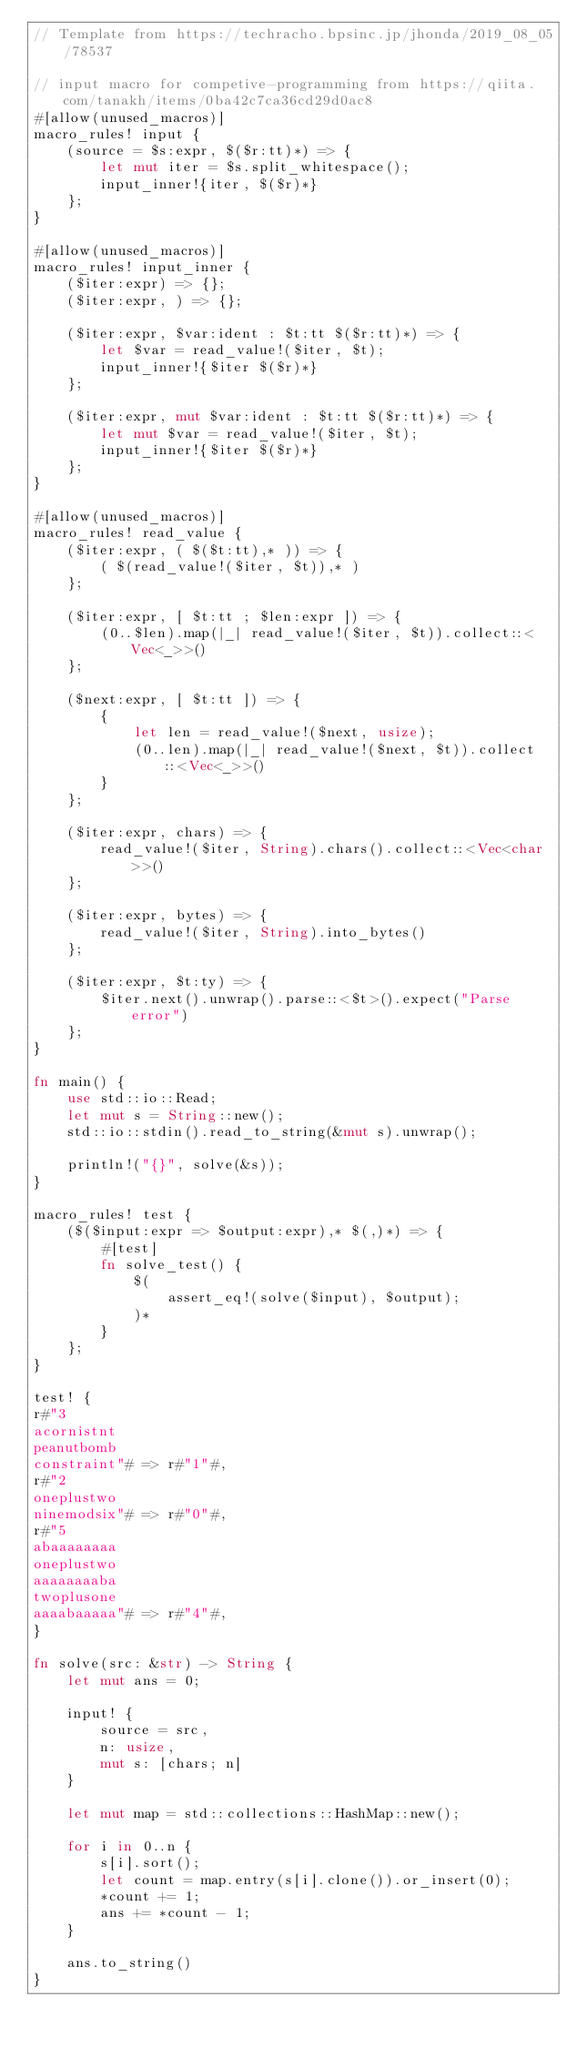<code> <loc_0><loc_0><loc_500><loc_500><_Rust_>// Template from https://techracho.bpsinc.jp/jhonda/2019_08_05/78537

// input macro for competive-programming from https://qiita.com/tanakh/items/0ba42c7ca36cd29d0ac8
#[allow(unused_macros)]
macro_rules! input {
    (source = $s:expr, $($r:tt)*) => {
        let mut iter = $s.split_whitespace();
        input_inner!{iter, $($r)*}
    };
}

#[allow(unused_macros)]
macro_rules! input_inner {
    ($iter:expr) => {};
    ($iter:expr, ) => {};

    ($iter:expr, $var:ident : $t:tt $($r:tt)*) => {
        let $var = read_value!($iter, $t);
        input_inner!{$iter $($r)*}
    };

    ($iter:expr, mut $var:ident : $t:tt $($r:tt)*) => {
        let mut $var = read_value!($iter, $t);
        input_inner!{$iter $($r)*}
    };
}

#[allow(unused_macros)]
macro_rules! read_value {
    ($iter:expr, ( $($t:tt),* )) => {
        ( $(read_value!($iter, $t)),* )
    };

    ($iter:expr, [ $t:tt ; $len:expr ]) => {
        (0..$len).map(|_| read_value!($iter, $t)).collect::<Vec<_>>()
    };

    ($next:expr, [ $t:tt ]) => {
        {
            let len = read_value!($next, usize);
            (0..len).map(|_| read_value!($next, $t)).collect::<Vec<_>>()
        }
    };

    ($iter:expr, chars) => {
        read_value!($iter, String).chars().collect::<Vec<char>>()
    };

    ($iter:expr, bytes) => {
        read_value!($iter, String).into_bytes()
    };

    ($iter:expr, $t:ty) => {
        $iter.next().unwrap().parse::<$t>().expect("Parse error")
    };
}

fn main() {
    use std::io::Read;
    let mut s = String::new();
    std::io::stdin().read_to_string(&mut s).unwrap();

    println!("{}", solve(&s));
}

macro_rules! test {
    ($($input:expr => $output:expr),* $(,)*) => {
        #[test]
        fn solve_test() {
            $(
                assert_eq!(solve($input), $output);
            )*
        }
    };
}

test! {
r#"3
acornistnt
peanutbomb
constraint"# => r#"1"#,
r#"2
oneplustwo
ninemodsix"# => r#"0"#,
r#"5
abaaaaaaaa
oneplustwo
aaaaaaaaba
twoplusone
aaaabaaaaa"# => r#"4"#,
}

fn solve(src: &str) -> String {
    let mut ans = 0;

    input! {
        source = src,
        n: usize,
        mut s: [chars; n]
    }

    let mut map = std::collections::HashMap::new();

    for i in 0..n {
        s[i].sort();
        let count = map.entry(s[i].clone()).or_insert(0);
        *count += 1;
        ans += *count - 1;
    }

    ans.to_string()
}</code> 